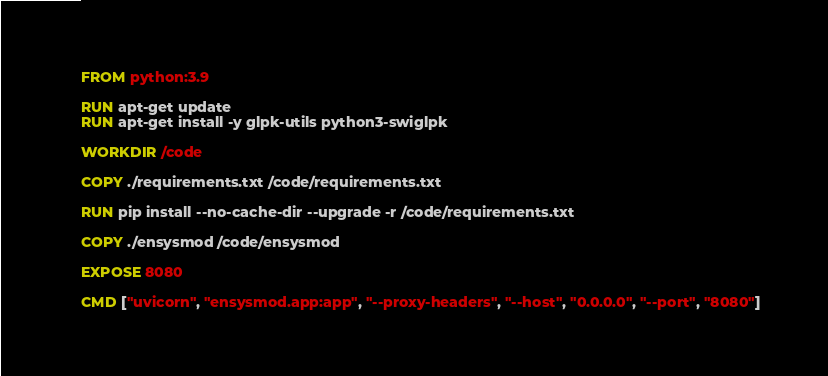Convert code to text. <code><loc_0><loc_0><loc_500><loc_500><_Dockerfile_>FROM python:3.9

RUN apt-get update
RUN apt-get install -y glpk-utils python3-swiglpk

WORKDIR /code

COPY ./requirements.txt /code/requirements.txt

RUN pip install --no-cache-dir --upgrade -r /code/requirements.txt

COPY ./ensysmod /code/ensysmod

EXPOSE 8080

CMD ["uvicorn", "ensysmod.app:app", "--proxy-headers", "--host", "0.0.0.0", "--port", "8080"]</code> 